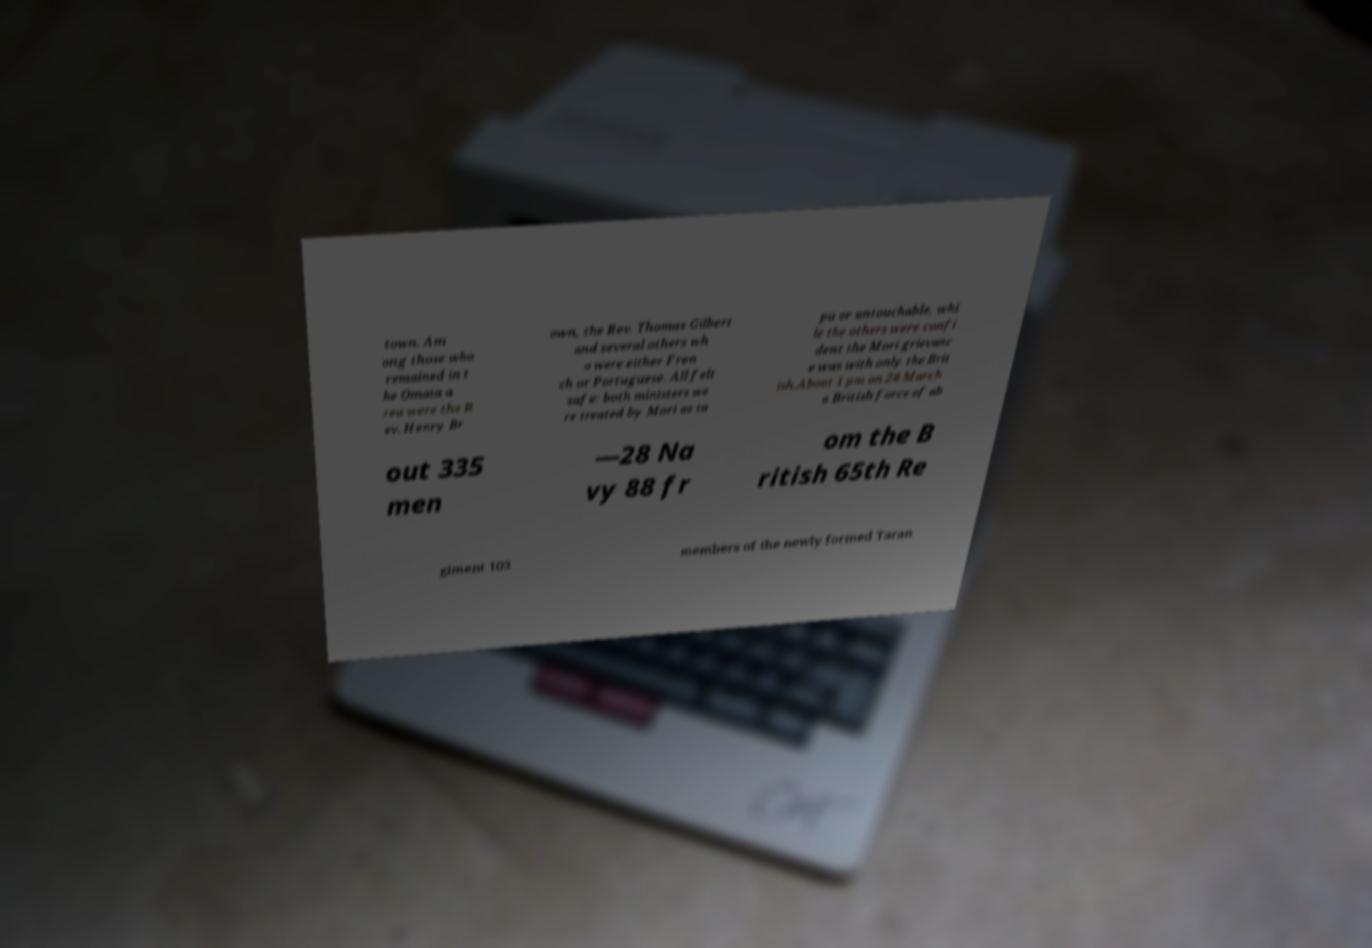Please read and relay the text visible in this image. What does it say? town. Am ong those who remained in t he Omata a rea were the R ev. Henry Br own, the Rev. Thomas Gilbert and several others wh o were either Fren ch or Portuguese. All felt safe: both ministers we re treated by Mori as ta pu or untouchable, whi le the others were confi dent the Mori grievanc e was with only the Brit ish.About 1 pm on 28 March a British force of ab out 335 men —28 Na vy 88 fr om the B ritish 65th Re giment 103 members of the newly formed Taran 